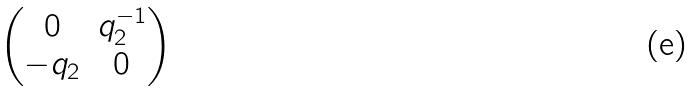<formula> <loc_0><loc_0><loc_500><loc_500>\begin{pmatrix} 0 & q _ { 2 } ^ { - 1 } \\ - q _ { 2 } & 0 \end{pmatrix}</formula> 